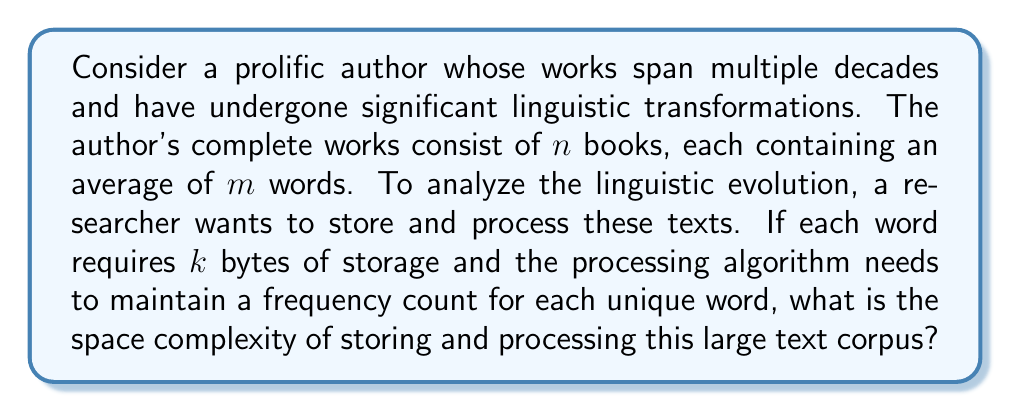Teach me how to tackle this problem. To determine the space complexity, we need to consider both the storage of the original text and the additional space required for processing:

1. Storing the original text:
   - Total number of words: $n \times m$
   - Storage per word: $k$ bytes
   - Total storage: $O(nmk)$ bytes

2. Processing the text:
   - We need to maintain a frequency count for each unique word
   - In the worst case, all words could be unique
   - A hash table can be used to store word-frequency pairs
   - Each entry in the hash table requires:
     * The word itself: $k$ bytes
     * A frequency counter: Assume 4 bytes (32-bit integer)
   - Total storage for the hash table: $O(nm(k + 4))$ bytes

3. Combining the storage requirements:
   - Original text: $O(nmk)$
   - Processing data structure: $O(nm(k + 4))$
   - Total space complexity: $O(nmk + nm(k + 4)) = O(nm(2k + 4))$

4. Simplifying:
   - The constant factors can be dropped in big O notation
   - Final space complexity: $O(nmk)$

This space complexity reflects the linear relationship between the total number of words $(nm)$ and the storage required per word $(k)$.
Answer: $O(nmk)$ 